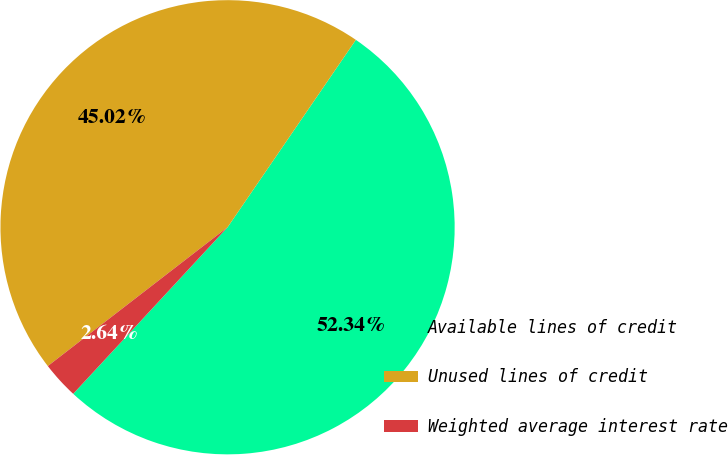<chart> <loc_0><loc_0><loc_500><loc_500><pie_chart><fcel>Available lines of credit<fcel>Unused lines of credit<fcel>Weighted average interest rate<nl><fcel>52.34%<fcel>45.02%<fcel>2.64%<nl></chart> 